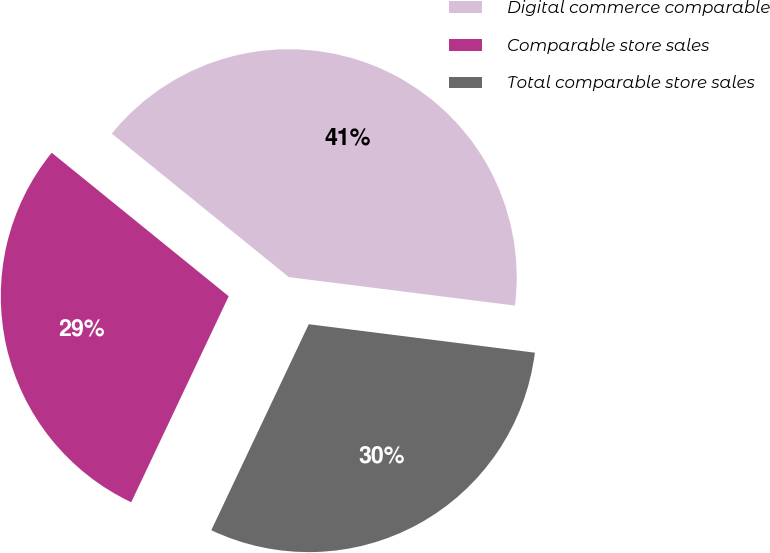<chart> <loc_0><loc_0><loc_500><loc_500><pie_chart><fcel>Digital commerce comparable<fcel>Comparable store sales<fcel>Total comparable store sales<nl><fcel>41.15%<fcel>28.81%<fcel>30.04%<nl></chart> 